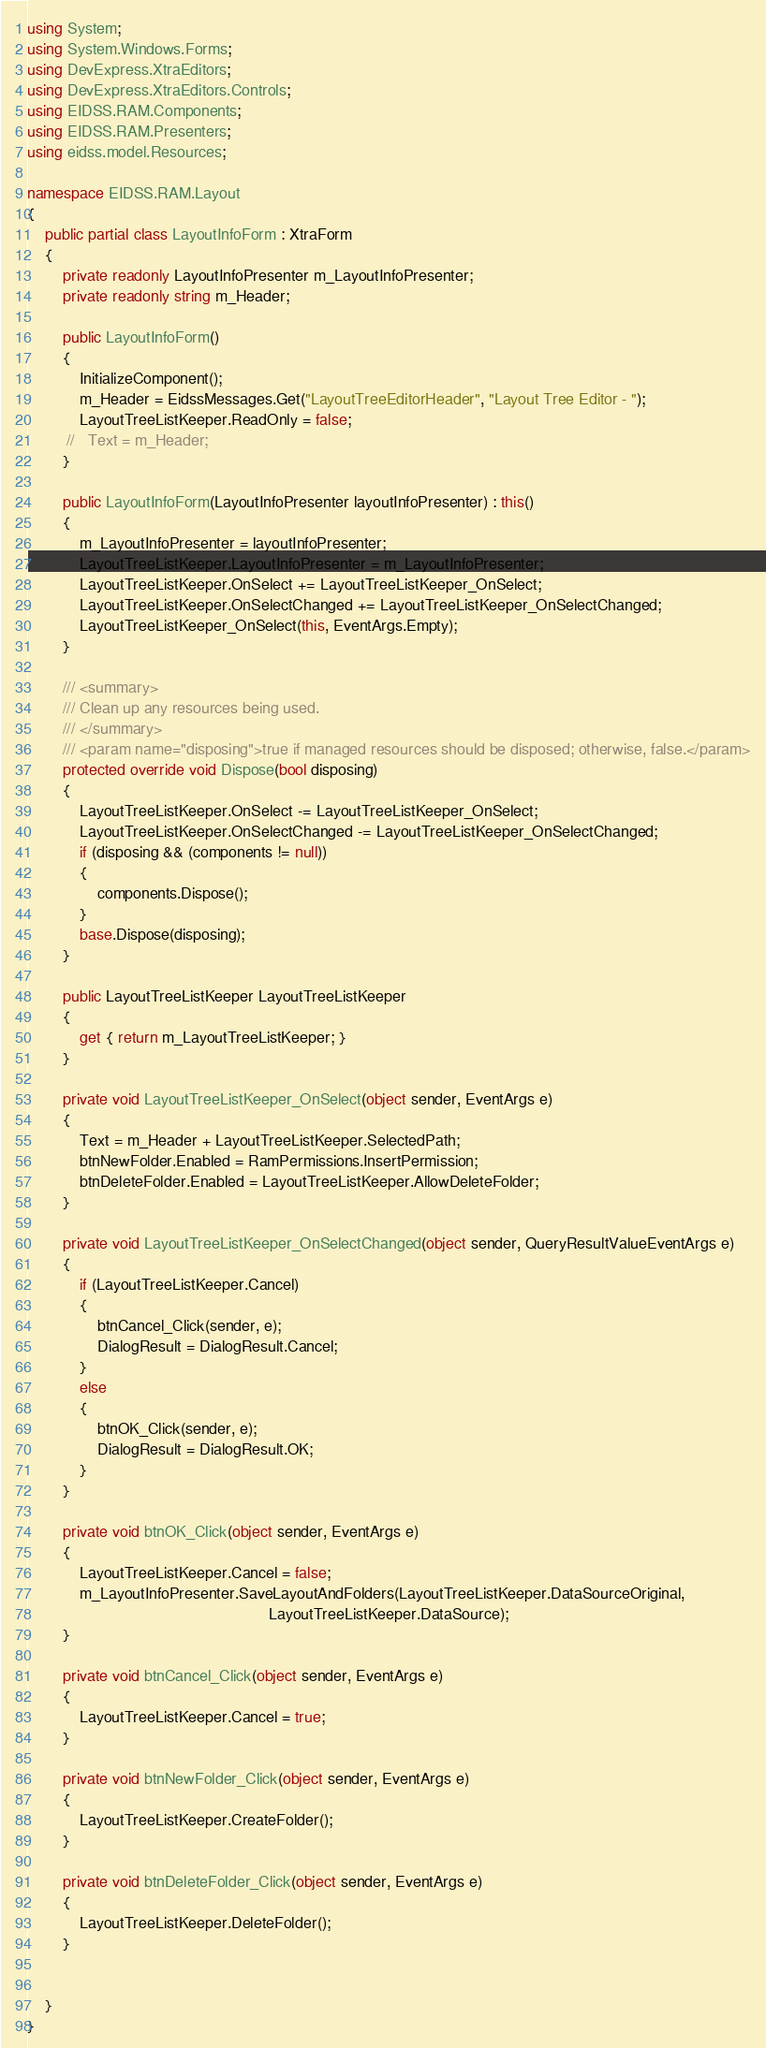<code> <loc_0><loc_0><loc_500><loc_500><_C#_>using System;
using System.Windows.Forms;
using DevExpress.XtraEditors;
using DevExpress.XtraEditors.Controls;
using EIDSS.RAM.Components;
using EIDSS.RAM.Presenters;
using eidss.model.Resources;

namespace EIDSS.RAM.Layout
{
    public partial class LayoutInfoForm : XtraForm
    {
        private readonly LayoutInfoPresenter m_LayoutInfoPresenter;
        private readonly string m_Header;

        public LayoutInfoForm()
        {
            InitializeComponent();
            m_Header = EidssMessages.Get("LayoutTreeEditorHeader", "Layout Tree Editor - ");
            LayoutTreeListKeeper.ReadOnly = false;
         //   Text = m_Header;
        }

        public LayoutInfoForm(LayoutInfoPresenter layoutInfoPresenter) : this()
        {
            m_LayoutInfoPresenter = layoutInfoPresenter;
            LayoutTreeListKeeper.LayoutInfoPresenter = m_LayoutInfoPresenter;
            LayoutTreeListKeeper.OnSelect += LayoutTreeListKeeper_OnSelect;
            LayoutTreeListKeeper.OnSelectChanged += LayoutTreeListKeeper_OnSelectChanged;
            LayoutTreeListKeeper_OnSelect(this, EventArgs.Empty);
        }

        /// <summary>
        /// Clean up any resources being used.
        /// </summary>
        /// <param name="disposing">true if managed resources should be disposed; otherwise, false.</param>
        protected override void Dispose(bool disposing)
        {
            LayoutTreeListKeeper.OnSelect -= LayoutTreeListKeeper_OnSelect;
            LayoutTreeListKeeper.OnSelectChanged -= LayoutTreeListKeeper_OnSelectChanged;
            if (disposing && (components != null))
            {
                components.Dispose();
            }
            base.Dispose(disposing);
        }

        public LayoutTreeListKeeper LayoutTreeListKeeper
        {
            get { return m_LayoutTreeListKeeper; }
        }

        private void LayoutTreeListKeeper_OnSelect(object sender, EventArgs e)
        {
            Text = m_Header + LayoutTreeListKeeper.SelectedPath;
            btnNewFolder.Enabled = RamPermissions.InsertPermission;
            btnDeleteFolder.Enabled = LayoutTreeListKeeper.AllowDeleteFolder;
        }

        private void LayoutTreeListKeeper_OnSelectChanged(object sender, QueryResultValueEventArgs e)
        {
            if (LayoutTreeListKeeper.Cancel)
            {
                btnCancel_Click(sender, e);
                DialogResult = DialogResult.Cancel;
            }
            else
            {
                btnOK_Click(sender, e);
                DialogResult = DialogResult.OK;
            }
        }

        private void btnOK_Click(object sender, EventArgs e)
        {
            LayoutTreeListKeeper.Cancel = false;
            m_LayoutInfoPresenter.SaveLayoutAndFolders(LayoutTreeListKeeper.DataSourceOriginal,
                                                       LayoutTreeListKeeper.DataSource);
        }

        private void btnCancel_Click(object sender, EventArgs e)
        {
            LayoutTreeListKeeper.Cancel = true;
        }

        private void btnNewFolder_Click(object sender, EventArgs e)
        {
            LayoutTreeListKeeper.CreateFolder();
        }

        private void btnDeleteFolder_Click(object sender, EventArgs e)
        {
            LayoutTreeListKeeper.DeleteFolder();
        }

      
    }
}</code> 